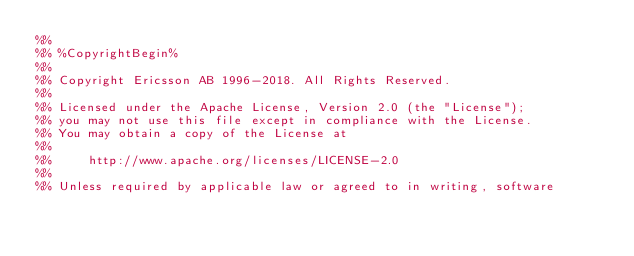<code> <loc_0><loc_0><loc_500><loc_500><_Erlang_>%%
%% %CopyrightBegin%
%%
%% Copyright Ericsson AB 1996-2018. All Rights Reserved.
%%
%% Licensed under the Apache License, Version 2.0 (the "License");
%% you may not use this file except in compliance with the License.
%% You may obtain a copy of the License at
%%
%%     http://www.apache.org/licenses/LICENSE-2.0
%%
%% Unless required by applicable law or agreed to in writing, software</code> 